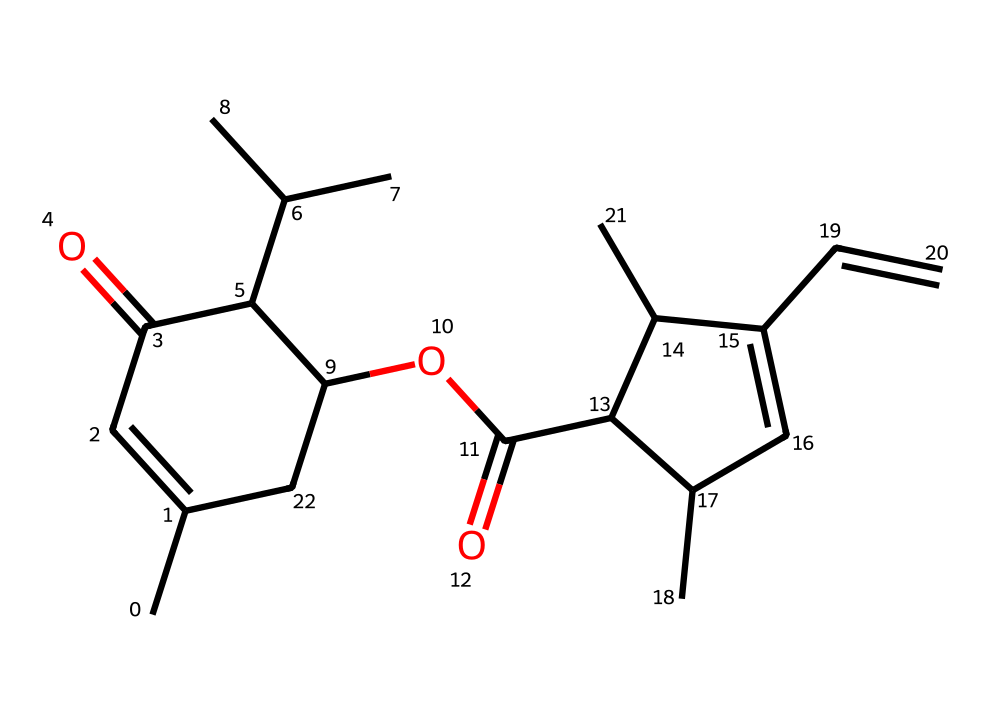How many carbon atoms are present in this chemical structure? By analyzing the SMILES representation of the chemical, we count all the carbon (C) symbols. The structure indicates the presence of 28 carbon atoms.
Answer: 28 What is the main functional group present in this chemical? The presence of the ester group is noted from the structure due to the -C(=O)O- pattern found within, indicating that the main functional group is an ester.
Answer: ester How many double bonds are in this chemical structure? Upon reviewing the structure, we see the presence of multiple carbon-carbon double bonds indicated by C=C. Counting these, we identify a total of four double bonds in the structure.
Answer: 4 What type of pesticide is pyrethrin classified as? Given that pyrethrin is derived from chrysanthemum flowers and acts on the neurological system of insects, it is classified as a natural insecticide, specifically an insect neurotoxin.
Answer: insecticide Which part of the chemical structure is likely responsible for its insecticidal activity? The presence of the aliphatic and cyclic arrangements combined with the reactive ester and double bonds strongly suggests the reactivity levels. This reactivity is often linked to neurotoxic activity against insect pests, meaning the entire structure as a whole contributes but particularly the ester and double-bond regions are significant.
Answer: ester and double bonds Which elements are present in the molecule apart from carbon? In addition to carbon, a comprehensive review of the SMILES string reveals the presence of oxygen (O) and hydrogen (H). These elements appear through functional groups like esters and the overall hydrogen saturation in the structure.
Answer: oxygen and hydrogen What is the molecular formula derived from this SMILES structure? To find the molecular formula, one counts the number of each type of atom from the SMILES representation. After identifying 28 carbons, 38 hydrogens, and 6 oxygens, the molecular formula can be summarized as C28H38O6.
Answer: C28H38O6 